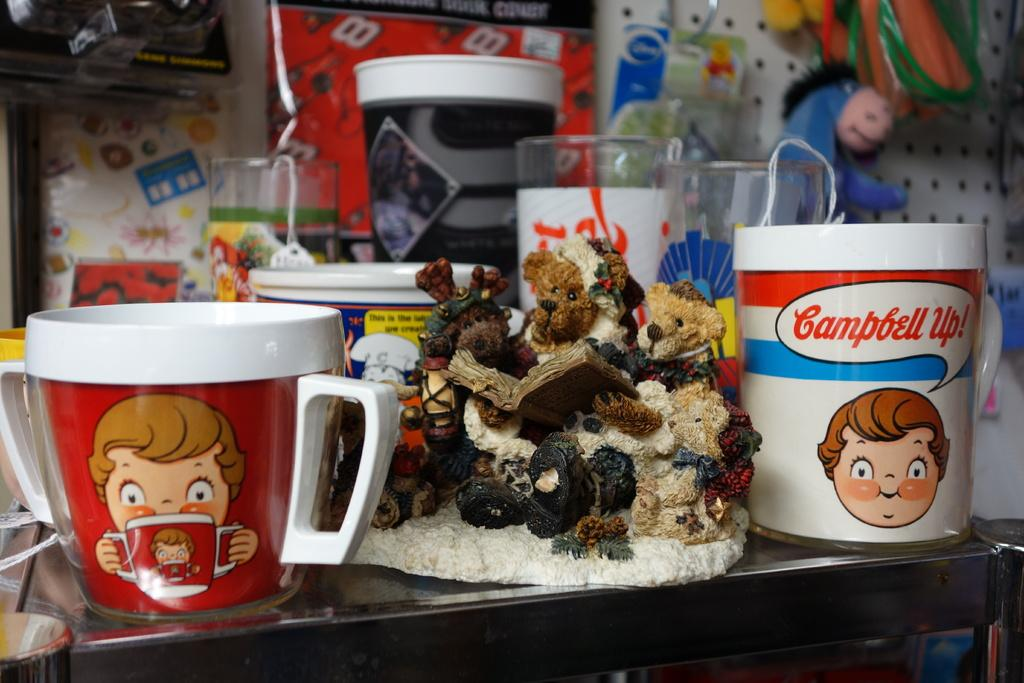What can be seen in the background of the image? There are objects in the background of the image, including a toy. What type of objects are visible in the image? Besides the toy, there are cups visible in the image. How many objects can be identified in the image? There are other few objects in the image, in addition to the toy and cups. What might be the setting of the image? The image appears to be set in a gift store. What type of chalk is being used to draw on the floor in the image? There is no chalk or drawing on the floor visible in the image. Can you tell me how many aunts are present in the image? There is no mention of an aunt or any people in the image. 